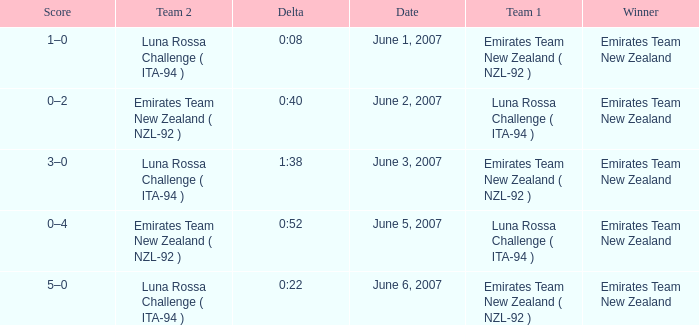On what Date is Delta 0:40? June 2, 2007. 